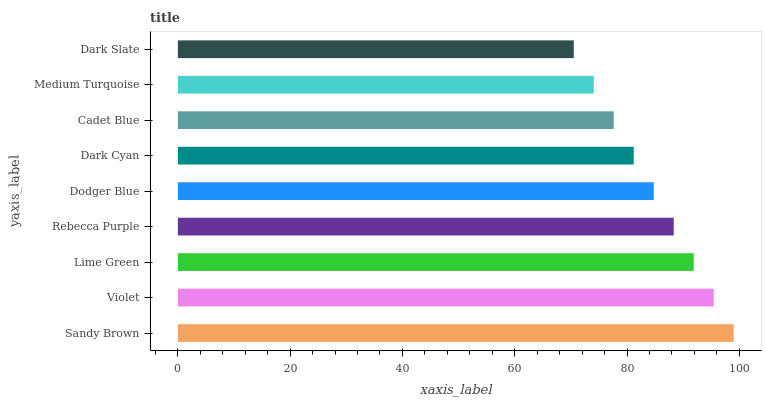Is Dark Slate the minimum?
Answer yes or no. Yes. Is Sandy Brown the maximum?
Answer yes or no. Yes. Is Violet the minimum?
Answer yes or no. No. Is Violet the maximum?
Answer yes or no. No. Is Sandy Brown greater than Violet?
Answer yes or no. Yes. Is Violet less than Sandy Brown?
Answer yes or no. Yes. Is Violet greater than Sandy Brown?
Answer yes or no. No. Is Sandy Brown less than Violet?
Answer yes or no. No. Is Dodger Blue the high median?
Answer yes or no. Yes. Is Dodger Blue the low median?
Answer yes or no. Yes. Is Cadet Blue the high median?
Answer yes or no. No. Is Dark Cyan the low median?
Answer yes or no. No. 